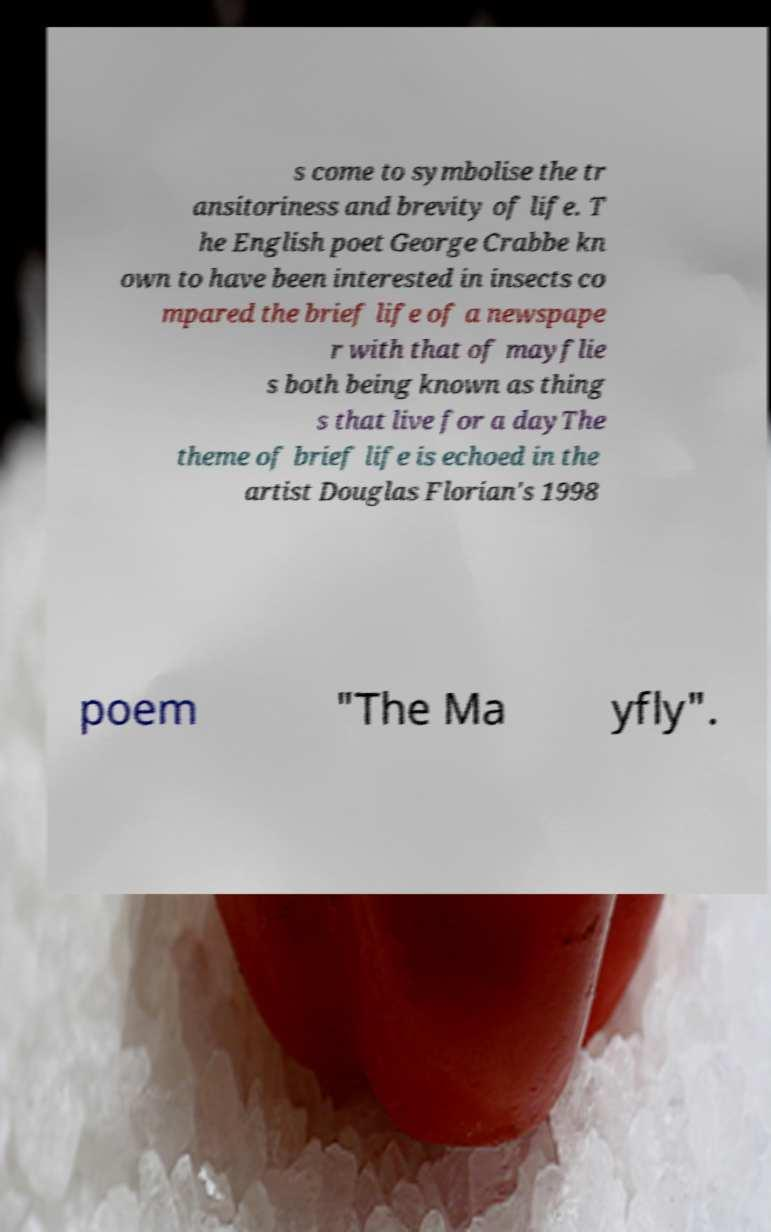Please identify and transcribe the text found in this image. s come to symbolise the tr ansitoriness and brevity of life. T he English poet George Crabbe kn own to have been interested in insects co mpared the brief life of a newspape r with that of mayflie s both being known as thing s that live for a dayThe theme of brief life is echoed in the artist Douglas Florian's 1998 poem "The Ma yfly". 